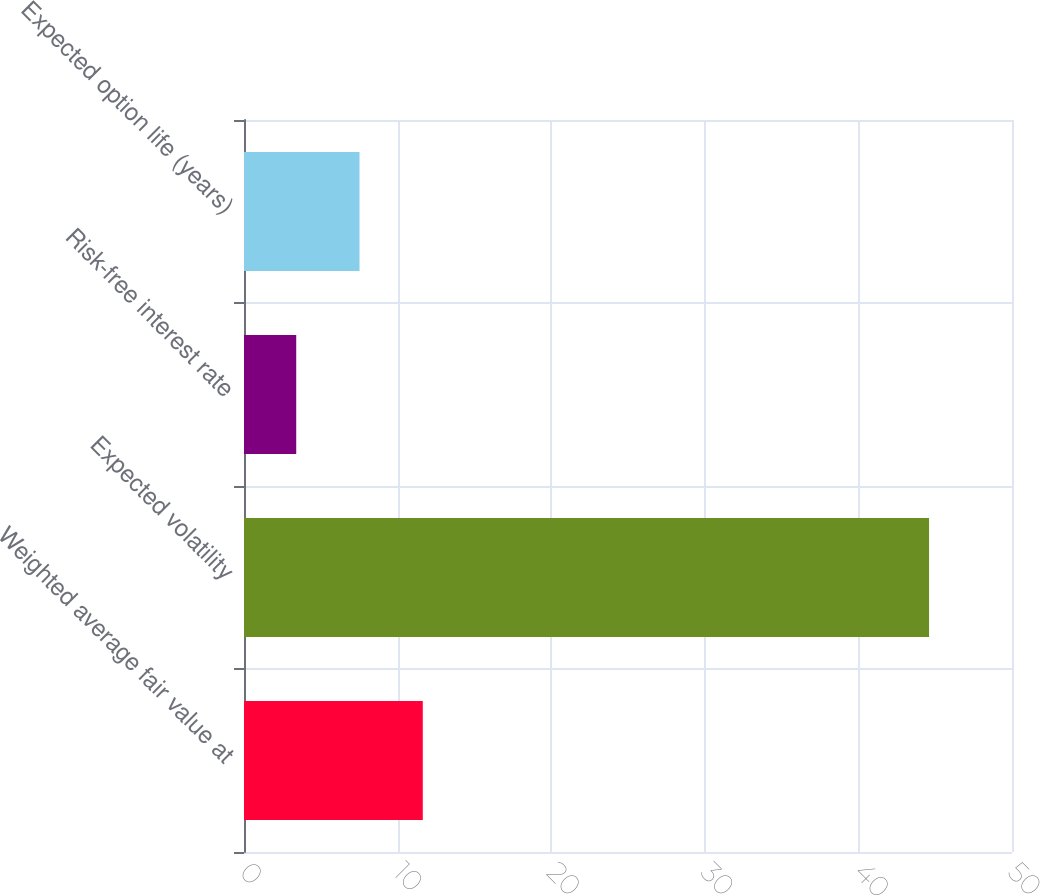<chart> <loc_0><loc_0><loc_500><loc_500><bar_chart><fcel>Weighted average fair value at<fcel>Expected volatility<fcel>Risk-free interest rate<fcel>Expected option life (years)<nl><fcel>11.64<fcel>44.6<fcel>3.4<fcel>7.52<nl></chart> 